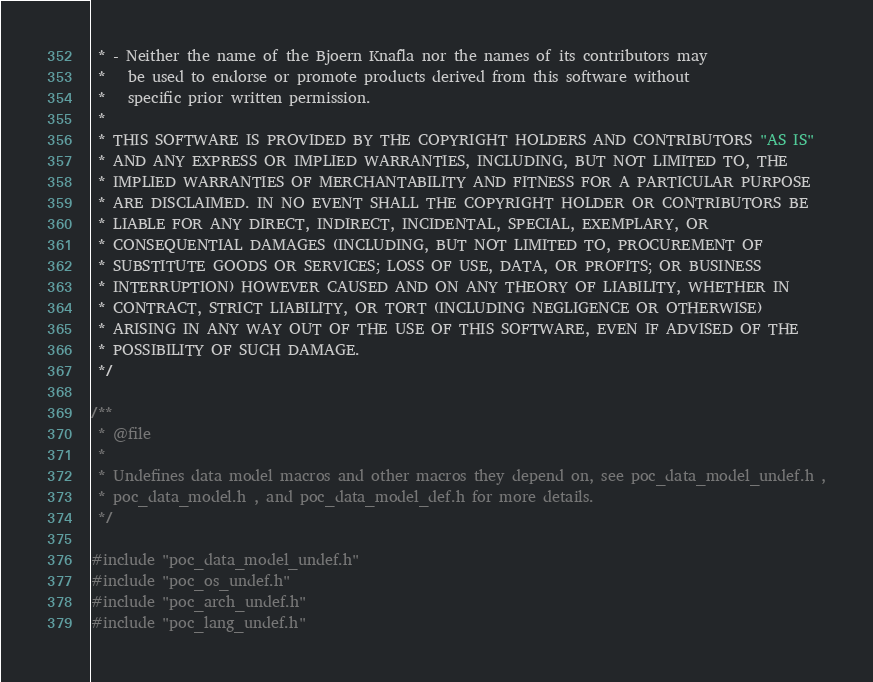Convert code to text. <code><loc_0><loc_0><loc_500><loc_500><_C_> * - Neither the name of the Bjoern Knafla nor the names of its contributors may 
 *   be used to endorse or promote products derived from this software without 
 *   specific prior written permission.
 *
 * THIS SOFTWARE IS PROVIDED BY THE COPYRIGHT HOLDERS AND CONTRIBUTORS "AS IS" 
 * AND ANY EXPRESS OR IMPLIED WARRANTIES, INCLUDING, BUT NOT LIMITED TO, THE 
 * IMPLIED WARRANTIES OF MERCHANTABILITY AND FITNESS FOR A PARTICULAR PURPOSE 
 * ARE DISCLAIMED. IN NO EVENT SHALL THE COPYRIGHT HOLDER OR CONTRIBUTORS BE 
 * LIABLE FOR ANY DIRECT, INDIRECT, INCIDENTAL, SPECIAL, EXEMPLARY, OR 
 * CONSEQUENTIAL DAMAGES (INCLUDING, BUT NOT LIMITED TO, PROCUREMENT OF 
 * SUBSTITUTE GOODS OR SERVICES; LOSS OF USE, DATA, OR PROFITS; OR BUSINESS 
 * INTERRUPTION) HOWEVER CAUSED AND ON ANY THEORY OF LIABILITY, WHETHER IN 
 * CONTRACT, STRICT LIABILITY, OR TORT (INCLUDING NEGLIGENCE OR OTHERWISE) 
 * ARISING IN ANY WAY OUT OF THE USE OF THIS SOFTWARE, EVEN IF ADVISED OF THE 
 * POSSIBILITY OF SUCH DAMAGE.
 */

/**
 * @file
 *
 * Undefines data model macros and other macros they depend on, see poc_data_model_undef.h ,
 * poc_data_model.h , and poc_data_model_def.h for more details.
 */

#include "poc_data_model_undef.h"
#include "poc_os_undef.h"
#include "poc_arch_undef.h"
#include "poc_lang_undef.h"
</code> 